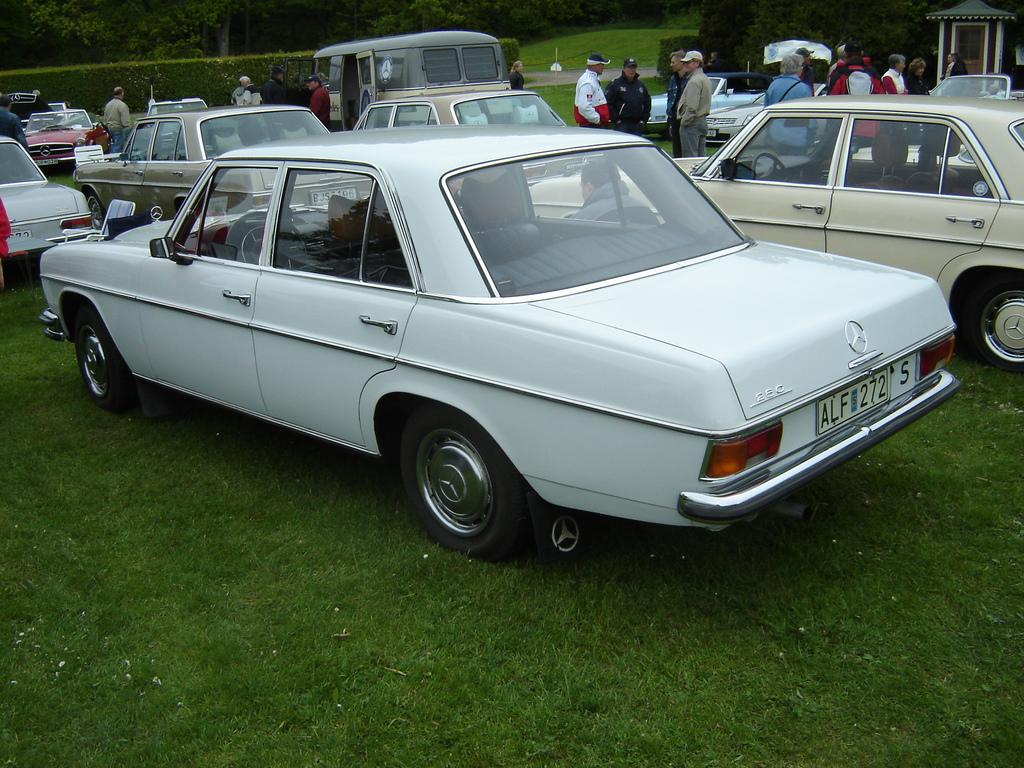What can be seen in the image that moves or transports people or goods? There are vehicles in the image that move or transport people or goods. What are the people in the image doing? The people in the image are standing on the ground. What type of natural environment is visible in the background of the image? There are trees and grass in the background of the image. Can you describe the unspecified object on the right side of the image? Unfortunately, the facts provided do not give any details about the object on the right side of the image. How does the image show an increase in the number of sacks being carried by the people? The image does not show any sacks being carried by the people, nor does it show an increase in the number of sacks. What type of competition is taking place in the image? There is no competition depicted in the image. 